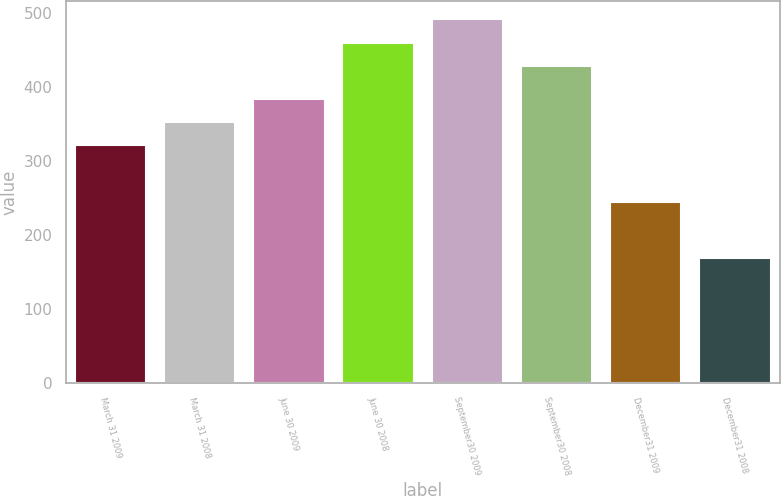Convert chart. <chart><loc_0><loc_0><loc_500><loc_500><bar_chart><fcel>March 31 2009<fcel>March 31 2008<fcel>June 30 2009<fcel>June 30 2008<fcel>September30 2009<fcel>September30 2008<fcel>December31 2009<fcel>December31 2008<nl><fcel>321<fcel>352.6<fcel>384.2<fcel>459.6<fcel>491.2<fcel>428<fcel>245<fcel>169<nl></chart> 